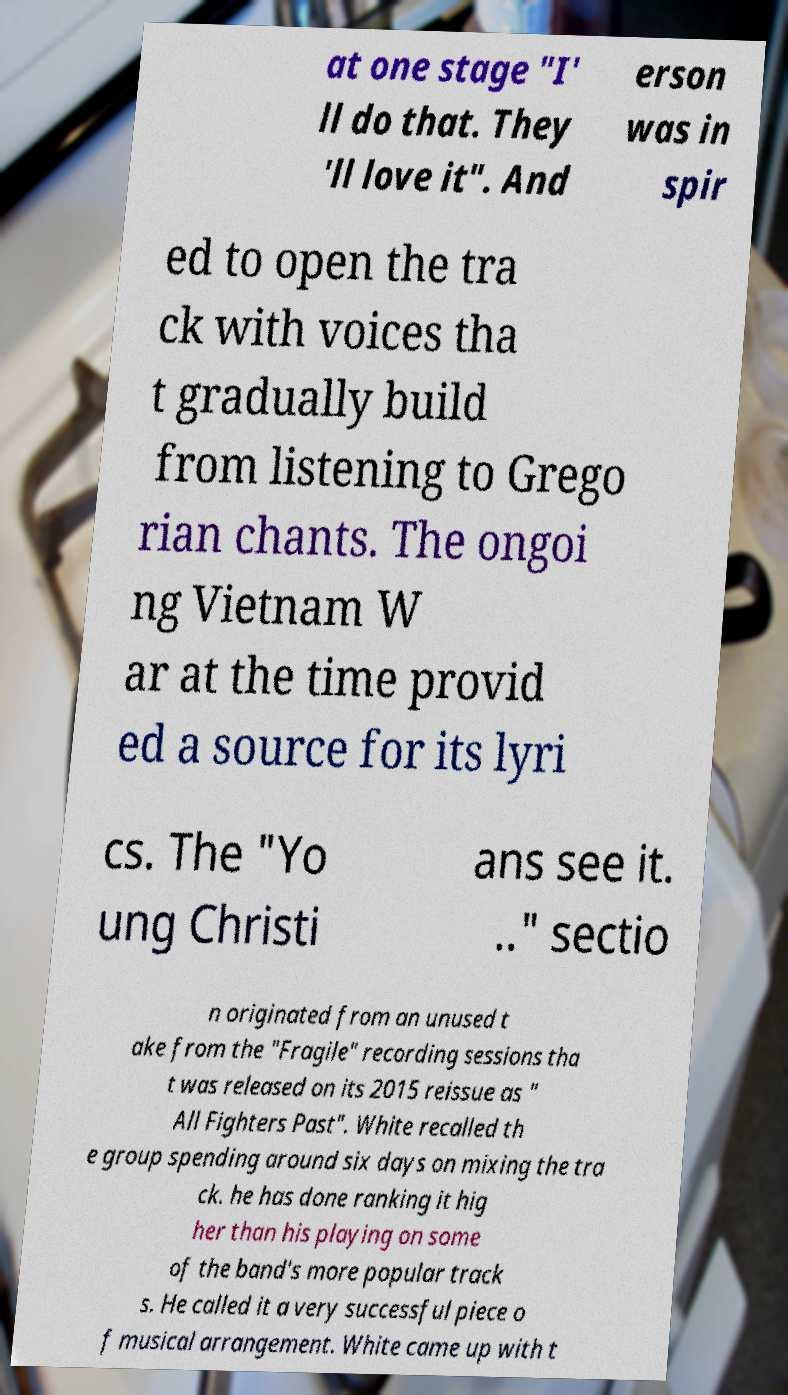Could you assist in decoding the text presented in this image and type it out clearly? at one stage "I' ll do that. They 'll love it". And erson was in spir ed to open the tra ck with voices tha t gradually build from listening to Grego rian chants. The ongoi ng Vietnam W ar at the time provid ed a source for its lyri cs. The "Yo ung Christi ans see it. .." sectio n originated from an unused t ake from the "Fragile" recording sessions tha t was released on its 2015 reissue as " All Fighters Past". White recalled th e group spending around six days on mixing the tra ck. he has done ranking it hig her than his playing on some of the band's more popular track s. He called it a very successful piece o f musical arrangement. White came up with t 